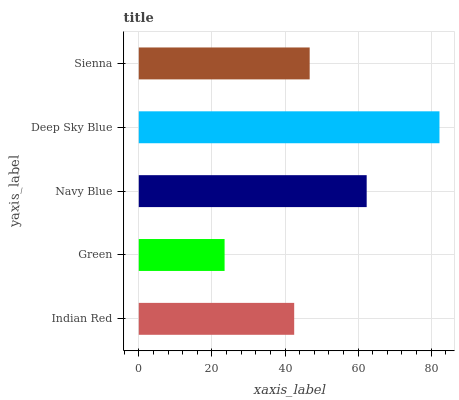Is Green the minimum?
Answer yes or no. Yes. Is Deep Sky Blue the maximum?
Answer yes or no. Yes. Is Navy Blue the minimum?
Answer yes or no. No. Is Navy Blue the maximum?
Answer yes or no. No. Is Navy Blue greater than Green?
Answer yes or no. Yes. Is Green less than Navy Blue?
Answer yes or no. Yes. Is Green greater than Navy Blue?
Answer yes or no. No. Is Navy Blue less than Green?
Answer yes or no. No. Is Sienna the high median?
Answer yes or no. Yes. Is Sienna the low median?
Answer yes or no. Yes. Is Indian Red the high median?
Answer yes or no. No. Is Navy Blue the low median?
Answer yes or no. No. 